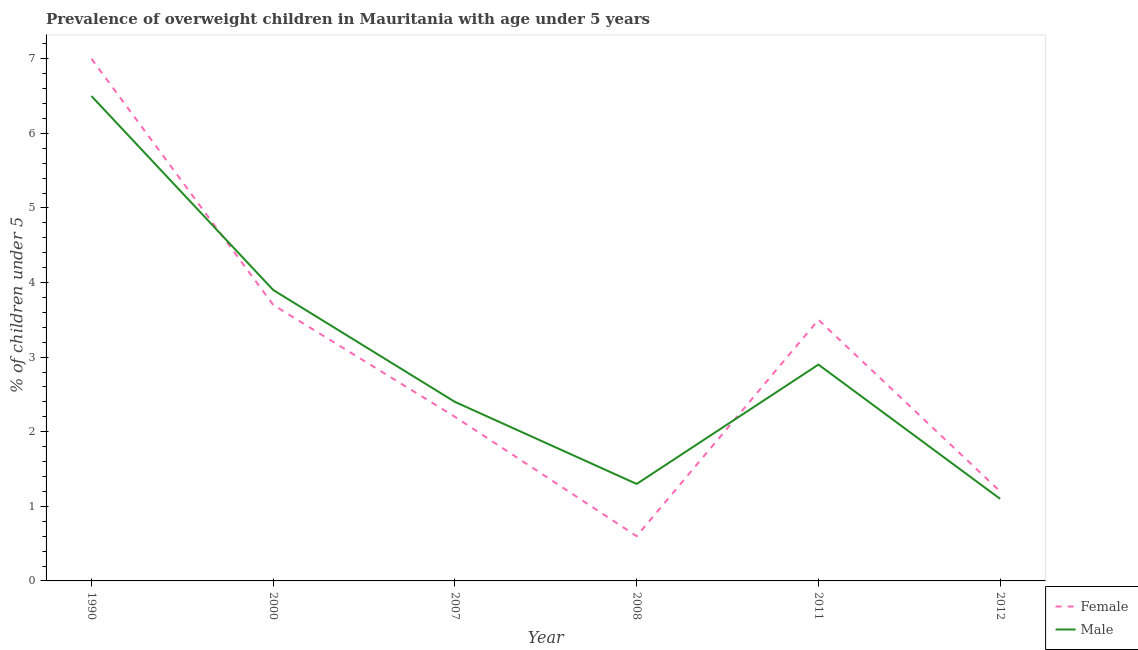How many different coloured lines are there?
Your answer should be very brief. 2. Is the number of lines equal to the number of legend labels?
Keep it short and to the point. Yes. What is the percentage of obese male children in 2000?
Give a very brief answer. 3.9. Across all years, what is the minimum percentage of obese female children?
Keep it short and to the point. 0.6. What is the total percentage of obese female children in the graph?
Ensure brevity in your answer.  18.2. What is the difference between the percentage of obese male children in 1990 and that in 2008?
Ensure brevity in your answer.  5.2. What is the difference between the percentage of obese male children in 2011 and the percentage of obese female children in 2000?
Ensure brevity in your answer.  -0.8. What is the average percentage of obese female children per year?
Provide a succinct answer. 3.03. In the year 2011, what is the difference between the percentage of obese female children and percentage of obese male children?
Your answer should be compact. 0.6. What is the ratio of the percentage of obese male children in 2000 to that in 2012?
Your answer should be compact. 3.55. Is the percentage of obese male children in 2007 less than that in 2011?
Provide a short and direct response. Yes. Is the difference between the percentage of obese male children in 2008 and 2011 greater than the difference between the percentage of obese female children in 2008 and 2011?
Give a very brief answer. Yes. What is the difference between the highest and the second highest percentage of obese female children?
Provide a succinct answer. 3.3. What is the difference between the highest and the lowest percentage of obese male children?
Your answer should be very brief. 5.4. In how many years, is the percentage of obese male children greater than the average percentage of obese male children taken over all years?
Offer a terse response. 2. How many years are there in the graph?
Offer a terse response. 6. What is the difference between two consecutive major ticks on the Y-axis?
Your answer should be very brief. 1. Does the graph contain grids?
Your answer should be very brief. No. Where does the legend appear in the graph?
Provide a short and direct response. Bottom right. What is the title of the graph?
Ensure brevity in your answer.  Prevalence of overweight children in Mauritania with age under 5 years. What is the label or title of the X-axis?
Offer a very short reply. Year. What is the label or title of the Y-axis?
Your response must be concise.  % of children under 5. What is the  % of children under 5 of Female in 1990?
Ensure brevity in your answer.  7. What is the  % of children under 5 in Male in 1990?
Provide a succinct answer. 6.5. What is the  % of children under 5 of Female in 2000?
Provide a succinct answer. 3.7. What is the  % of children under 5 in Male in 2000?
Offer a terse response. 3.9. What is the  % of children under 5 of Female in 2007?
Offer a very short reply. 2.2. What is the  % of children under 5 of Male in 2007?
Offer a terse response. 2.4. What is the  % of children under 5 in Female in 2008?
Your response must be concise. 0.6. What is the  % of children under 5 of Male in 2008?
Provide a succinct answer. 1.3. What is the  % of children under 5 in Female in 2011?
Offer a very short reply. 3.5. What is the  % of children under 5 of Male in 2011?
Offer a terse response. 2.9. What is the  % of children under 5 of Female in 2012?
Your answer should be compact. 1.2. What is the  % of children under 5 in Male in 2012?
Keep it short and to the point. 1.1. Across all years, what is the maximum  % of children under 5 in Male?
Offer a very short reply. 6.5. Across all years, what is the minimum  % of children under 5 of Female?
Offer a terse response. 0.6. Across all years, what is the minimum  % of children under 5 in Male?
Your answer should be compact. 1.1. What is the total  % of children under 5 in Female in the graph?
Keep it short and to the point. 18.2. What is the difference between the  % of children under 5 in Male in 1990 and that in 2008?
Make the answer very short. 5.2. What is the difference between the  % of children under 5 of Female in 1990 and that in 2011?
Your answer should be compact. 3.5. What is the difference between the  % of children under 5 of Male in 1990 and that in 2012?
Give a very brief answer. 5.4. What is the difference between the  % of children under 5 in Female in 2000 and that in 2007?
Offer a terse response. 1.5. What is the difference between the  % of children under 5 in Male in 2000 and that in 2007?
Your answer should be very brief. 1.5. What is the difference between the  % of children under 5 in Female in 2000 and that in 2008?
Offer a terse response. 3.1. What is the difference between the  % of children under 5 of Male in 2000 and that in 2008?
Give a very brief answer. 2.6. What is the difference between the  % of children under 5 of Female in 2000 and that in 2011?
Your answer should be compact. 0.2. What is the difference between the  % of children under 5 in Male in 2000 and that in 2011?
Give a very brief answer. 1. What is the difference between the  % of children under 5 in Female in 2007 and that in 2011?
Offer a very short reply. -1.3. What is the difference between the  % of children under 5 in Female in 2007 and that in 2012?
Offer a terse response. 1. What is the difference between the  % of children under 5 in Male in 2007 and that in 2012?
Offer a very short reply. 1.3. What is the difference between the  % of children under 5 in Male in 2008 and that in 2012?
Your answer should be compact. 0.2. What is the difference between the  % of children under 5 in Male in 2011 and that in 2012?
Ensure brevity in your answer.  1.8. What is the difference between the  % of children under 5 in Female in 1990 and the  % of children under 5 in Male in 2007?
Keep it short and to the point. 4.6. What is the difference between the  % of children under 5 of Female in 1990 and the  % of children under 5 of Male in 2008?
Your response must be concise. 5.7. What is the difference between the  % of children under 5 of Female in 1990 and the  % of children under 5 of Male in 2011?
Ensure brevity in your answer.  4.1. What is the difference between the  % of children under 5 in Female in 1990 and the  % of children under 5 in Male in 2012?
Provide a short and direct response. 5.9. What is the difference between the  % of children under 5 in Female in 2000 and the  % of children under 5 in Male in 2011?
Offer a very short reply. 0.8. What is the difference between the  % of children under 5 in Female in 2007 and the  % of children under 5 in Male in 2008?
Offer a terse response. 0.9. What is the difference between the  % of children under 5 in Female in 2007 and the  % of children under 5 in Male in 2011?
Provide a succinct answer. -0.7. What is the difference between the  % of children under 5 of Female in 2008 and the  % of children under 5 of Male in 2012?
Your answer should be compact. -0.5. What is the average  % of children under 5 in Female per year?
Make the answer very short. 3.03. What is the average  % of children under 5 in Male per year?
Offer a very short reply. 3.02. In the year 2011, what is the difference between the  % of children under 5 of Female and  % of children under 5 of Male?
Make the answer very short. 0.6. What is the ratio of the  % of children under 5 in Female in 1990 to that in 2000?
Keep it short and to the point. 1.89. What is the ratio of the  % of children under 5 of Female in 1990 to that in 2007?
Give a very brief answer. 3.18. What is the ratio of the  % of children under 5 in Male in 1990 to that in 2007?
Keep it short and to the point. 2.71. What is the ratio of the  % of children under 5 of Female in 1990 to that in 2008?
Make the answer very short. 11.67. What is the ratio of the  % of children under 5 of Male in 1990 to that in 2011?
Your answer should be compact. 2.24. What is the ratio of the  % of children under 5 in Female in 1990 to that in 2012?
Make the answer very short. 5.83. What is the ratio of the  % of children under 5 of Male in 1990 to that in 2012?
Offer a very short reply. 5.91. What is the ratio of the  % of children under 5 in Female in 2000 to that in 2007?
Your response must be concise. 1.68. What is the ratio of the  % of children under 5 in Male in 2000 to that in 2007?
Ensure brevity in your answer.  1.62. What is the ratio of the  % of children under 5 in Female in 2000 to that in 2008?
Your response must be concise. 6.17. What is the ratio of the  % of children under 5 in Male in 2000 to that in 2008?
Ensure brevity in your answer.  3. What is the ratio of the  % of children under 5 in Female in 2000 to that in 2011?
Ensure brevity in your answer.  1.06. What is the ratio of the  % of children under 5 of Male in 2000 to that in 2011?
Your answer should be compact. 1.34. What is the ratio of the  % of children under 5 of Female in 2000 to that in 2012?
Offer a terse response. 3.08. What is the ratio of the  % of children under 5 of Male in 2000 to that in 2012?
Provide a succinct answer. 3.55. What is the ratio of the  % of children under 5 of Female in 2007 to that in 2008?
Offer a very short reply. 3.67. What is the ratio of the  % of children under 5 in Male in 2007 to that in 2008?
Your response must be concise. 1.85. What is the ratio of the  % of children under 5 in Female in 2007 to that in 2011?
Your answer should be very brief. 0.63. What is the ratio of the  % of children under 5 of Male in 2007 to that in 2011?
Your answer should be very brief. 0.83. What is the ratio of the  % of children under 5 in Female in 2007 to that in 2012?
Make the answer very short. 1.83. What is the ratio of the  % of children under 5 of Male in 2007 to that in 2012?
Provide a short and direct response. 2.18. What is the ratio of the  % of children under 5 in Female in 2008 to that in 2011?
Give a very brief answer. 0.17. What is the ratio of the  % of children under 5 in Male in 2008 to that in 2011?
Keep it short and to the point. 0.45. What is the ratio of the  % of children under 5 in Female in 2008 to that in 2012?
Your answer should be compact. 0.5. What is the ratio of the  % of children under 5 in Male in 2008 to that in 2012?
Offer a terse response. 1.18. What is the ratio of the  % of children under 5 in Female in 2011 to that in 2012?
Make the answer very short. 2.92. What is the ratio of the  % of children under 5 of Male in 2011 to that in 2012?
Ensure brevity in your answer.  2.64. What is the difference between the highest and the second highest  % of children under 5 in Female?
Your answer should be compact. 3.3. What is the difference between the highest and the lowest  % of children under 5 of Male?
Ensure brevity in your answer.  5.4. 